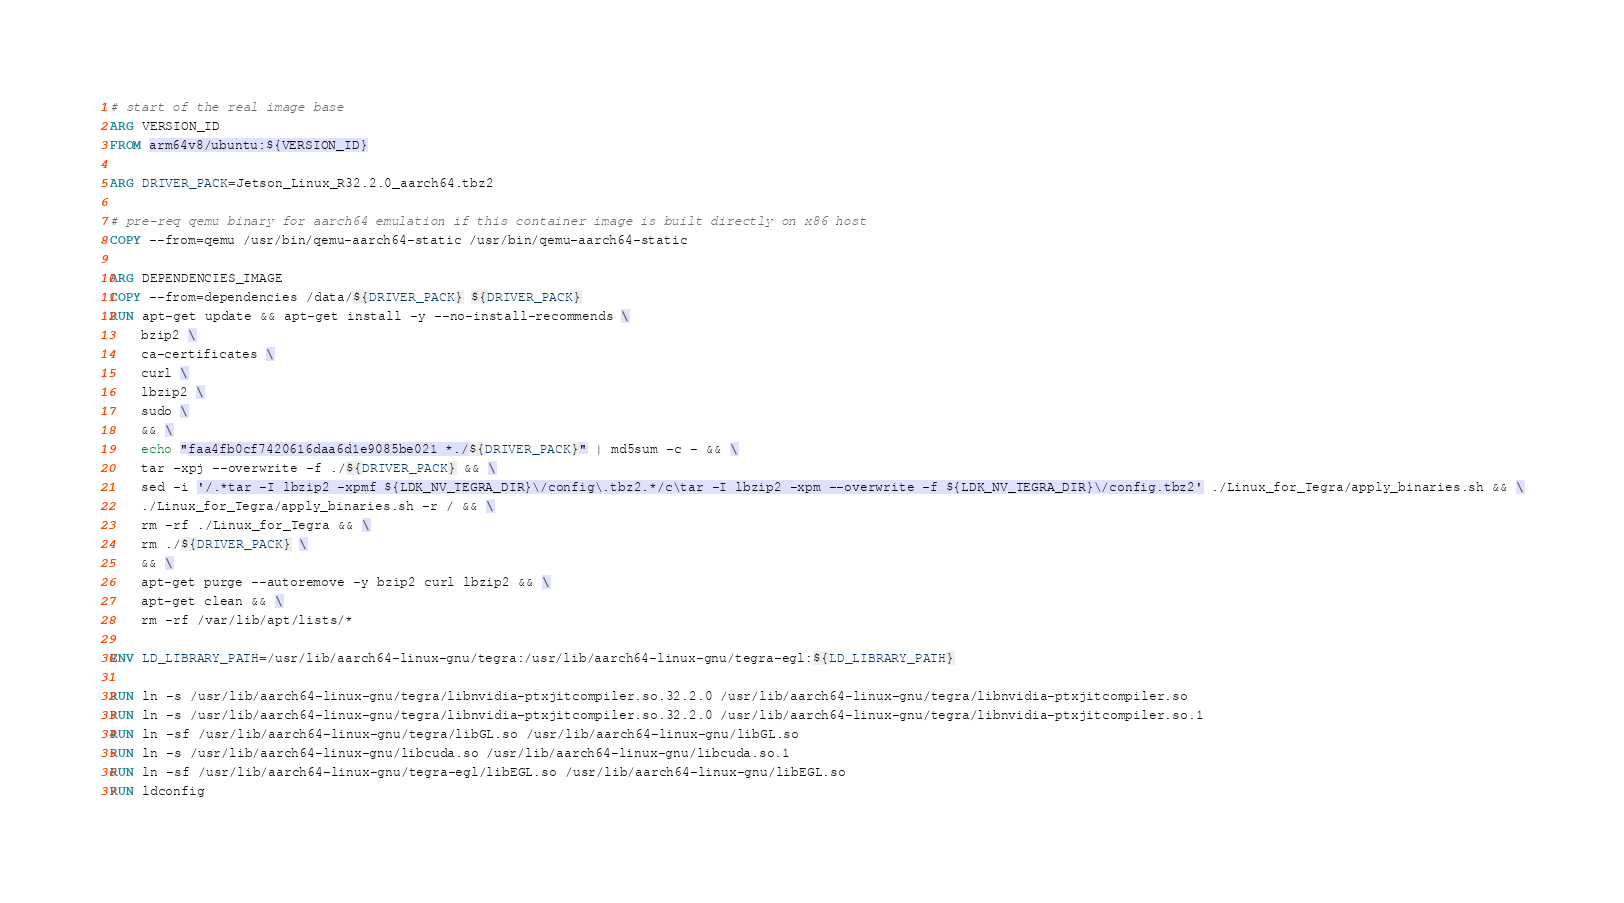Convert code to text. <code><loc_0><loc_0><loc_500><loc_500><_Dockerfile_># start of the real image base
ARG VERSION_ID
FROM arm64v8/ubuntu:${VERSION_ID}

ARG DRIVER_PACK=Jetson_Linux_R32.2.0_aarch64.tbz2

# pre-req qemu binary for aarch64 emulation if this container image is built directly on x86 host
COPY --from=qemu /usr/bin/qemu-aarch64-static /usr/bin/qemu-aarch64-static

ARG DEPENDENCIES_IMAGE
COPY --from=dependencies /data/${DRIVER_PACK} ${DRIVER_PACK}
RUN apt-get update && apt-get install -y --no-install-recommends \
    bzip2 \
    ca-certificates \
    curl \
    lbzip2 \
    sudo \
    && \
    echo "faa4fb0cf7420616daa6d1e9085be021 *./${DRIVER_PACK}" | md5sum -c - && \
    tar -xpj --overwrite -f ./${DRIVER_PACK} && \
    sed -i '/.*tar -I lbzip2 -xpmf ${LDK_NV_TEGRA_DIR}\/config\.tbz2.*/c\tar -I lbzip2 -xpm --overwrite -f ${LDK_NV_TEGRA_DIR}\/config.tbz2' ./Linux_for_Tegra/apply_binaries.sh && \
    ./Linux_for_Tegra/apply_binaries.sh -r / && \
    rm -rf ./Linux_for_Tegra && \
    rm ./${DRIVER_PACK} \
    && \
    apt-get purge --autoremove -y bzip2 curl lbzip2 && \
    apt-get clean && \
    rm -rf /var/lib/apt/lists/*

ENV LD_LIBRARY_PATH=/usr/lib/aarch64-linux-gnu/tegra:/usr/lib/aarch64-linux-gnu/tegra-egl:${LD_LIBRARY_PATH}

RUN ln -s /usr/lib/aarch64-linux-gnu/tegra/libnvidia-ptxjitcompiler.so.32.2.0 /usr/lib/aarch64-linux-gnu/tegra/libnvidia-ptxjitcompiler.so
RUN ln -s /usr/lib/aarch64-linux-gnu/tegra/libnvidia-ptxjitcompiler.so.32.2.0 /usr/lib/aarch64-linux-gnu/tegra/libnvidia-ptxjitcompiler.so.1
RUN ln -sf /usr/lib/aarch64-linux-gnu/tegra/libGL.so /usr/lib/aarch64-linux-gnu/libGL.so
RUN ln -s /usr/lib/aarch64-linux-gnu/libcuda.so /usr/lib/aarch64-linux-gnu/libcuda.so.1
RUN ln -sf /usr/lib/aarch64-linux-gnu/tegra-egl/libEGL.so /usr/lib/aarch64-linux-gnu/libEGL.so
RUN ldconfig
</code> 